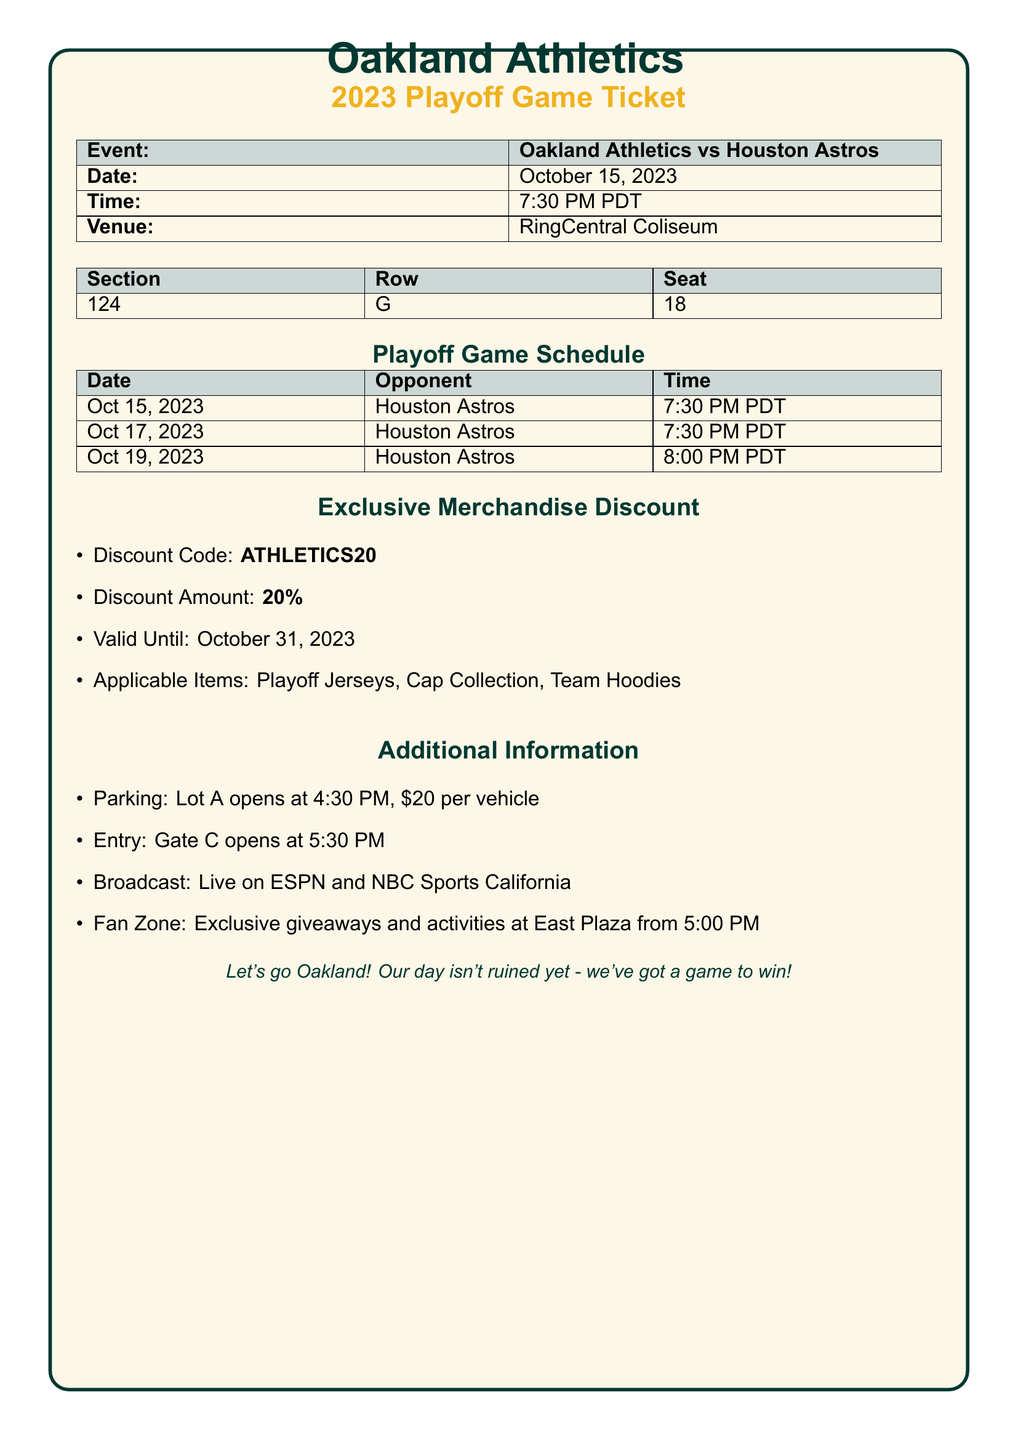what is the event? The event is detailed in the document, which states it is the matchup between the Oakland Athletics and the Houston Astros.
Answer: Oakland Athletics vs Houston Astros what is the date of the game? The date of the game is listed in the document under the event details.
Answer: October 15, 2023 what time does the game start? The starting time of the game is provided in the event section of the document.
Answer: 7:30 PM PDT what is the seat location? The seat location is specified in a table detailing the section, row, and seat.
Answer: Section 124, Row G, Seat 18 how many playoff games are scheduled? A count of the games listed in the playoff game schedule indicates the total number.
Answer: 3 what is the discount code for merchandise? The document provides a discount code for merchandise under the exclusive merchandise discount section.
Answer: ATHLETICS20 what is the discount percentage? The discount amount is clearly specified in the merchandise section of the ticket.
Answer: 20% when do the gates open for entry? The entry time is mentioned as a specific opening time for the gate in the additional information.
Answer: 5:30 PM what time does Lot A open for parking? The parking lot opening time is provided in the document, highlighting essential pre-game details.
Answer: 4:30 PM 